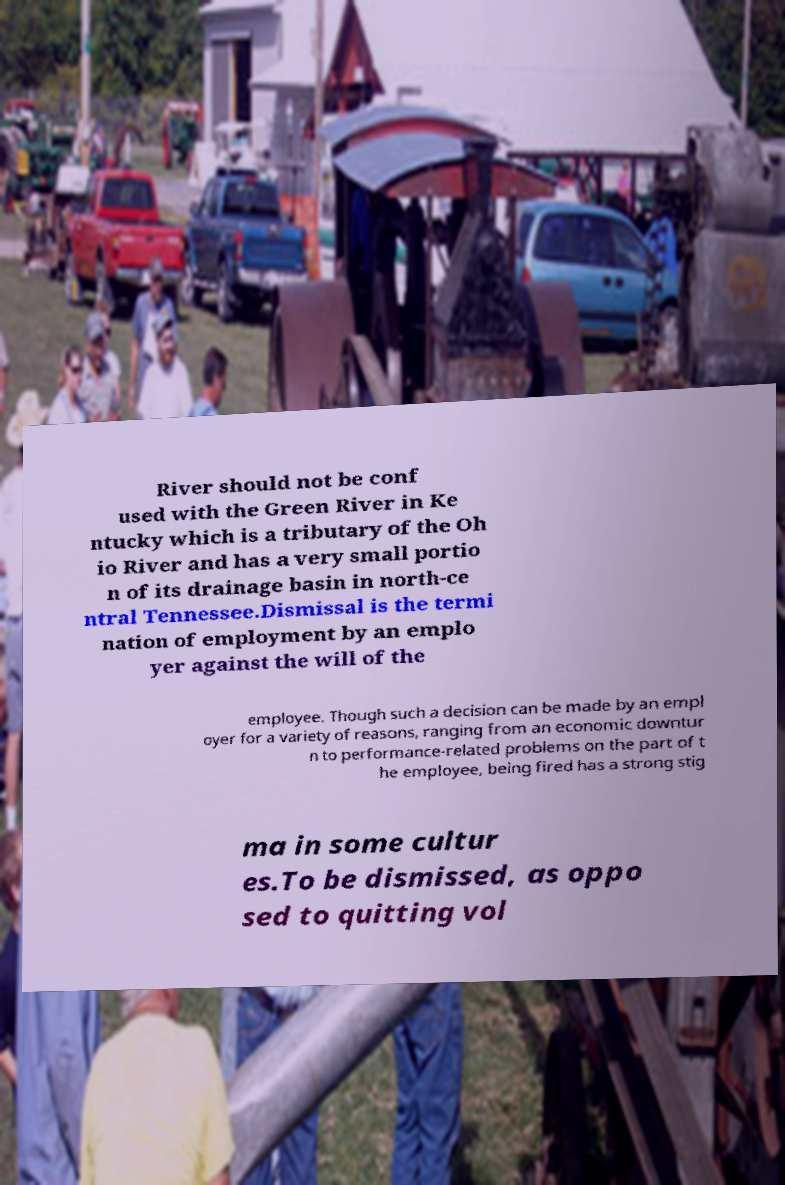I need the written content from this picture converted into text. Can you do that? River should not be conf used with the Green River in Ke ntucky which is a tributary of the Oh io River and has a very small portio n of its drainage basin in north-ce ntral Tennessee.Dismissal is the termi nation of employment by an emplo yer against the will of the employee. Though such a decision can be made by an empl oyer for a variety of reasons, ranging from an economic downtur n to performance-related problems on the part of t he employee, being fired has a strong stig ma in some cultur es.To be dismissed, as oppo sed to quitting vol 